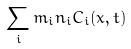<formula> <loc_0><loc_0><loc_500><loc_500>\sum _ { i } m _ { i } n _ { i } C _ { i } ( x , t )</formula> 